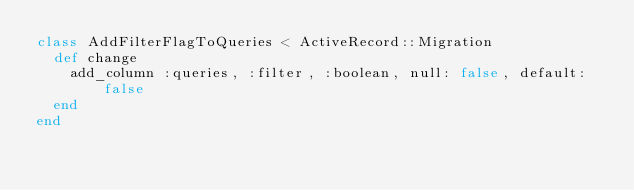<code> <loc_0><loc_0><loc_500><loc_500><_Ruby_>class AddFilterFlagToQueries < ActiveRecord::Migration
  def change
    add_column :queries, :filter, :boolean, null: false, default: false
  end
end
</code> 